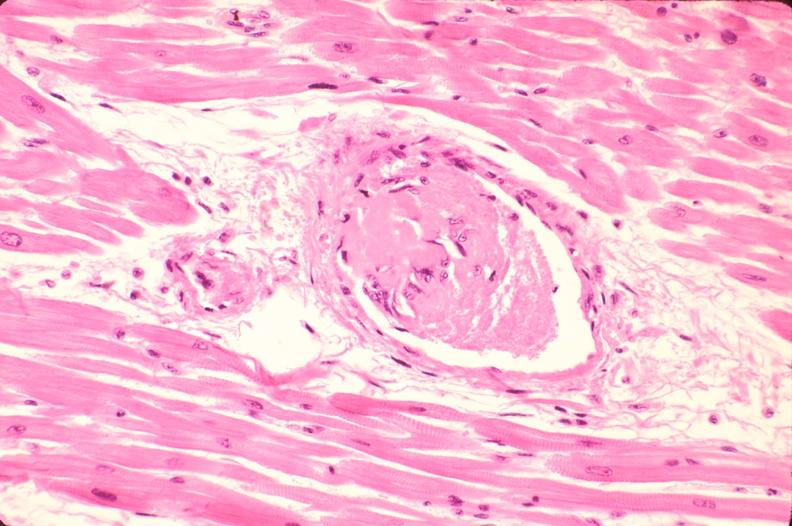s cardiovascular present?
Answer the question using a single word or phrase. Yes 